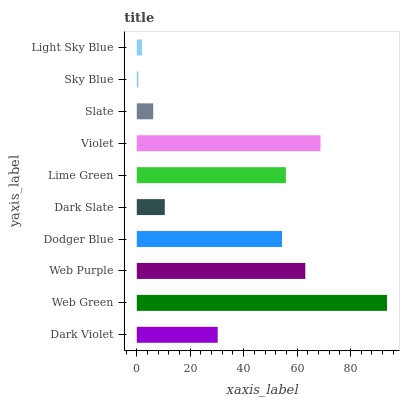Is Sky Blue the minimum?
Answer yes or no. Yes. Is Web Green the maximum?
Answer yes or no. Yes. Is Web Purple the minimum?
Answer yes or no. No. Is Web Purple the maximum?
Answer yes or no. No. Is Web Green greater than Web Purple?
Answer yes or no. Yes. Is Web Purple less than Web Green?
Answer yes or no. Yes. Is Web Purple greater than Web Green?
Answer yes or no. No. Is Web Green less than Web Purple?
Answer yes or no. No. Is Dodger Blue the high median?
Answer yes or no. Yes. Is Dark Violet the low median?
Answer yes or no. Yes. Is Lime Green the high median?
Answer yes or no. No. Is Web Green the low median?
Answer yes or no. No. 